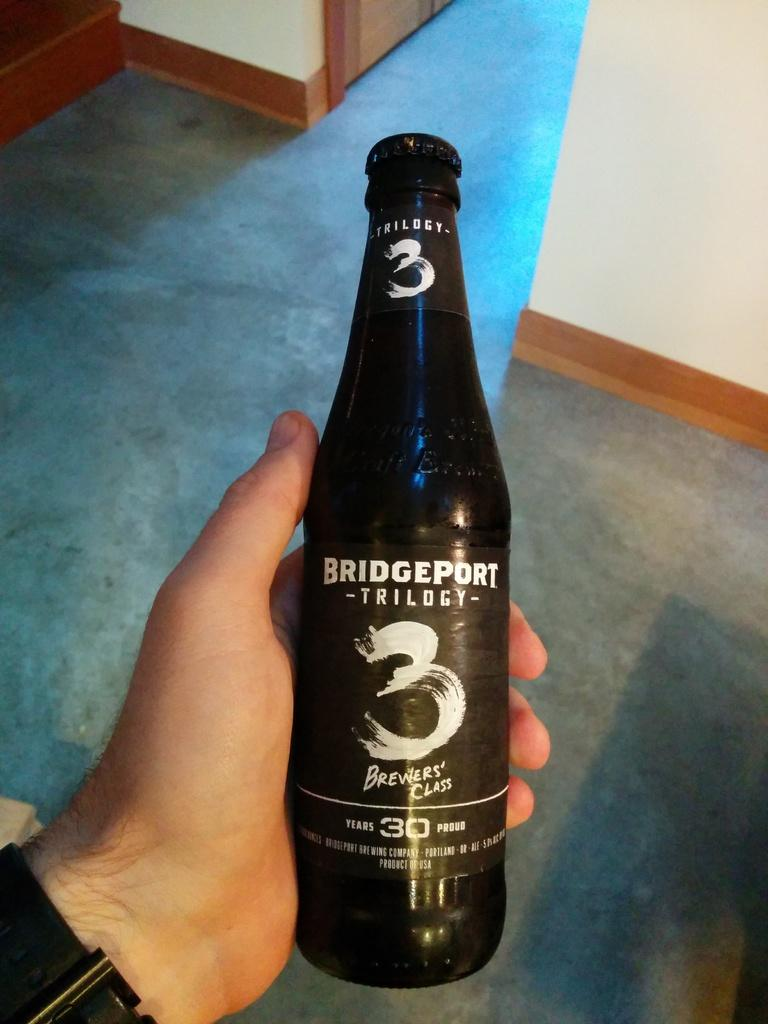<image>
Offer a succinct explanation of the picture presented. Person holding a black beer bottle which says Bridgeport on it. 